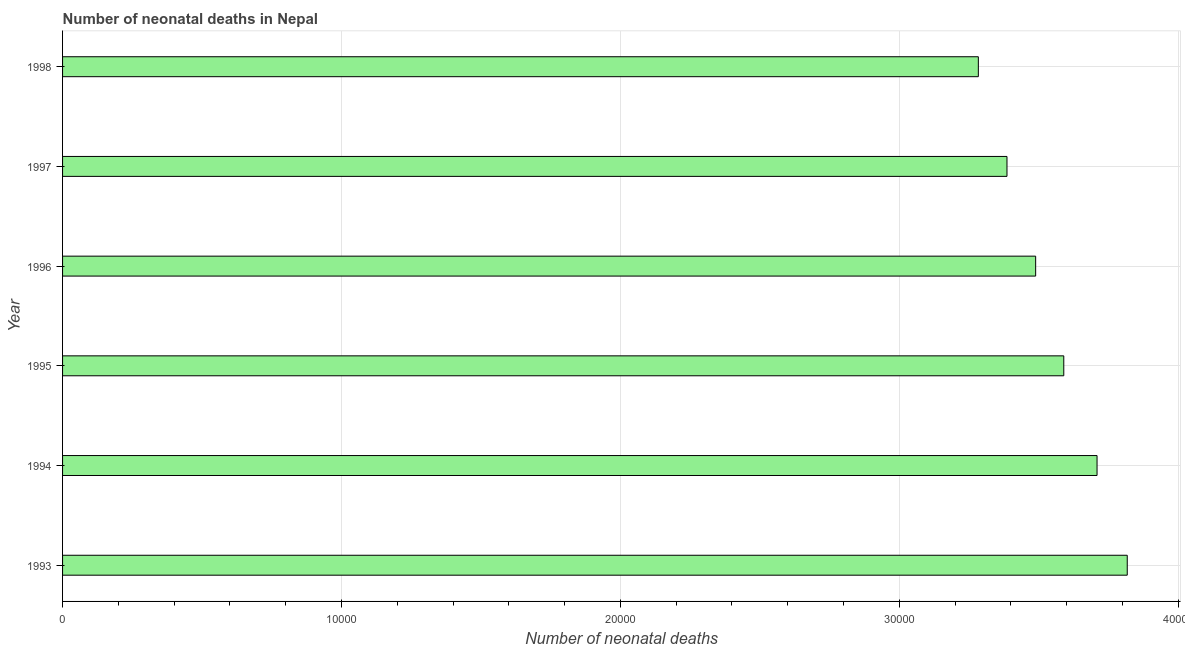Does the graph contain any zero values?
Provide a succinct answer. No. What is the title of the graph?
Your answer should be compact. Number of neonatal deaths in Nepal. What is the label or title of the X-axis?
Your response must be concise. Number of neonatal deaths. What is the number of neonatal deaths in 1997?
Offer a terse response. 3.39e+04. Across all years, what is the maximum number of neonatal deaths?
Ensure brevity in your answer.  3.82e+04. Across all years, what is the minimum number of neonatal deaths?
Provide a short and direct response. 3.28e+04. In which year was the number of neonatal deaths minimum?
Offer a terse response. 1998. What is the sum of the number of neonatal deaths?
Your response must be concise. 2.13e+05. What is the difference between the number of neonatal deaths in 1996 and 1998?
Your answer should be compact. 2055. What is the average number of neonatal deaths per year?
Make the answer very short. 3.55e+04. What is the median number of neonatal deaths?
Make the answer very short. 3.54e+04. What is the difference between the highest and the second highest number of neonatal deaths?
Ensure brevity in your answer.  1083. What is the difference between the highest and the lowest number of neonatal deaths?
Provide a succinct answer. 5339. In how many years, is the number of neonatal deaths greater than the average number of neonatal deaths taken over all years?
Provide a short and direct response. 3. Are all the bars in the graph horizontal?
Your answer should be very brief. Yes. How many years are there in the graph?
Give a very brief answer. 6. What is the difference between two consecutive major ticks on the X-axis?
Your answer should be very brief. 10000. Are the values on the major ticks of X-axis written in scientific E-notation?
Ensure brevity in your answer.  No. What is the Number of neonatal deaths in 1993?
Provide a short and direct response. 3.82e+04. What is the Number of neonatal deaths of 1994?
Your answer should be very brief. 3.71e+04. What is the Number of neonatal deaths in 1995?
Your answer should be very brief. 3.59e+04. What is the Number of neonatal deaths of 1996?
Provide a short and direct response. 3.49e+04. What is the Number of neonatal deaths in 1997?
Offer a terse response. 3.39e+04. What is the Number of neonatal deaths in 1998?
Your answer should be very brief. 3.28e+04. What is the difference between the Number of neonatal deaths in 1993 and 1994?
Provide a short and direct response. 1083. What is the difference between the Number of neonatal deaths in 1993 and 1995?
Offer a terse response. 2276. What is the difference between the Number of neonatal deaths in 1993 and 1996?
Your answer should be very brief. 3284. What is the difference between the Number of neonatal deaths in 1993 and 1997?
Provide a succinct answer. 4312. What is the difference between the Number of neonatal deaths in 1993 and 1998?
Provide a succinct answer. 5339. What is the difference between the Number of neonatal deaths in 1994 and 1995?
Provide a succinct answer. 1193. What is the difference between the Number of neonatal deaths in 1994 and 1996?
Give a very brief answer. 2201. What is the difference between the Number of neonatal deaths in 1994 and 1997?
Keep it short and to the point. 3229. What is the difference between the Number of neonatal deaths in 1994 and 1998?
Offer a very short reply. 4256. What is the difference between the Number of neonatal deaths in 1995 and 1996?
Offer a very short reply. 1008. What is the difference between the Number of neonatal deaths in 1995 and 1997?
Make the answer very short. 2036. What is the difference between the Number of neonatal deaths in 1995 and 1998?
Provide a short and direct response. 3063. What is the difference between the Number of neonatal deaths in 1996 and 1997?
Keep it short and to the point. 1028. What is the difference between the Number of neonatal deaths in 1996 and 1998?
Keep it short and to the point. 2055. What is the difference between the Number of neonatal deaths in 1997 and 1998?
Your response must be concise. 1027. What is the ratio of the Number of neonatal deaths in 1993 to that in 1994?
Give a very brief answer. 1.03. What is the ratio of the Number of neonatal deaths in 1993 to that in 1995?
Keep it short and to the point. 1.06. What is the ratio of the Number of neonatal deaths in 1993 to that in 1996?
Make the answer very short. 1.09. What is the ratio of the Number of neonatal deaths in 1993 to that in 1997?
Your response must be concise. 1.13. What is the ratio of the Number of neonatal deaths in 1993 to that in 1998?
Offer a very short reply. 1.16. What is the ratio of the Number of neonatal deaths in 1994 to that in 1995?
Your response must be concise. 1.03. What is the ratio of the Number of neonatal deaths in 1994 to that in 1996?
Ensure brevity in your answer.  1.06. What is the ratio of the Number of neonatal deaths in 1994 to that in 1997?
Your answer should be compact. 1.09. What is the ratio of the Number of neonatal deaths in 1994 to that in 1998?
Provide a short and direct response. 1.13. What is the ratio of the Number of neonatal deaths in 1995 to that in 1996?
Offer a terse response. 1.03. What is the ratio of the Number of neonatal deaths in 1995 to that in 1997?
Your answer should be very brief. 1.06. What is the ratio of the Number of neonatal deaths in 1995 to that in 1998?
Give a very brief answer. 1.09. What is the ratio of the Number of neonatal deaths in 1996 to that in 1997?
Provide a short and direct response. 1.03. What is the ratio of the Number of neonatal deaths in 1996 to that in 1998?
Ensure brevity in your answer.  1.06. What is the ratio of the Number of neonatal deaths in 1997 to that in 1998?
Give a very brief answer. 1.03. 